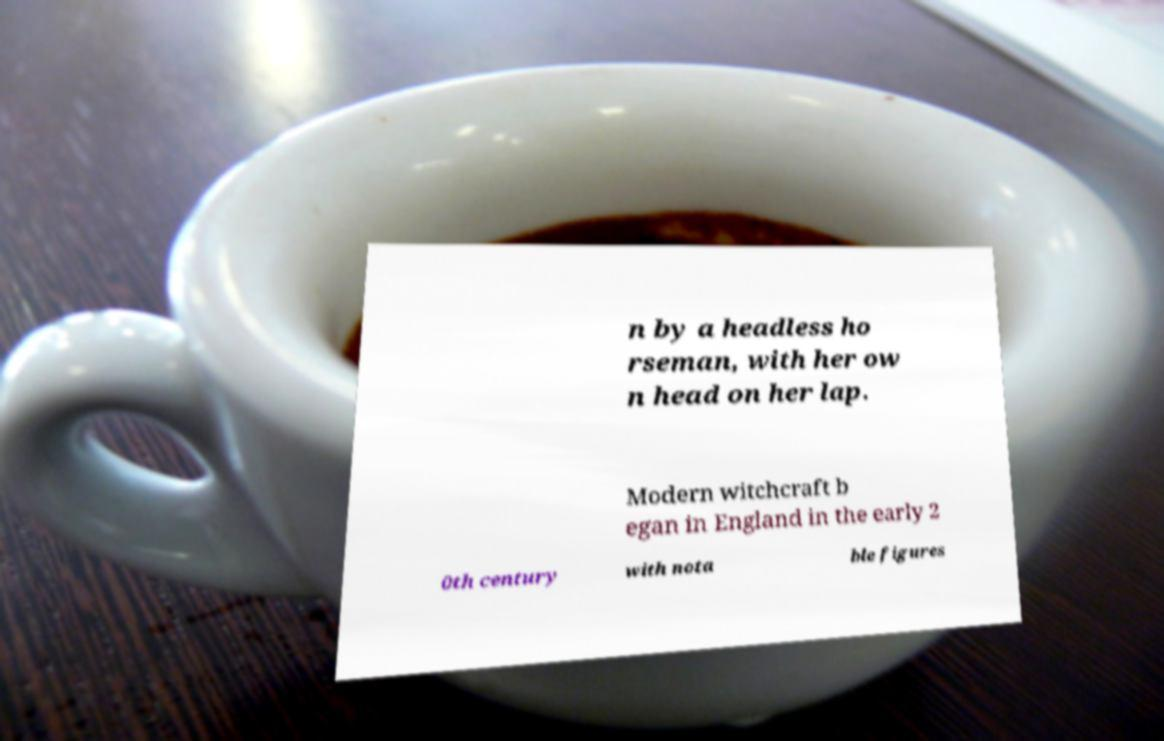Could you assist in decoding the text presented in this image and type it out clearly? n by a headless ho rseman, with her ow n head on her lap. Modern witchcraft b egan in England in the early 2 0th century with nota ble figures 